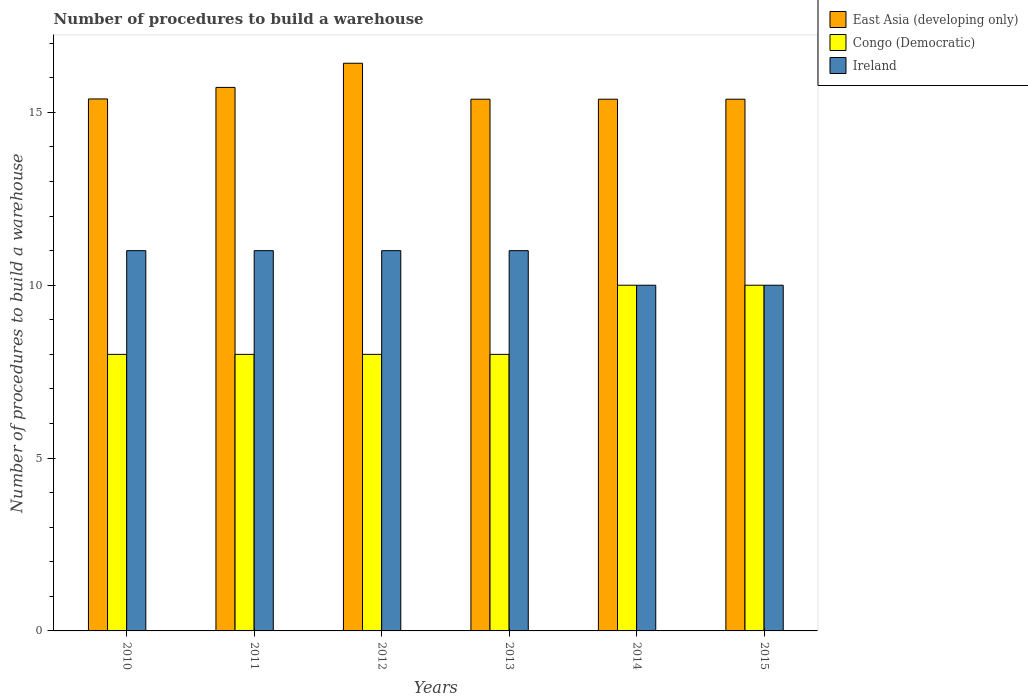How many groups of bars are there?
Provide a succinct answer. 6. Are the number of bars per tick equal to the number of legend labels?
Provide a succinct answer. Yes. How many bars are there on the 2nd tick from the right?
Provide a succinct answer. 3. What is the label of the 2nd group of bars from the left?
Keep it short and to the point. 2011. What is the number of procedures to build a warehouse in in East Asia (developing only) in 2014?
Keep it short and to the point. 15.38. Across all years, what is the maximum number of procedures to build a warehouse in in East Asia (developing only)?
Keep it short and to the point. 16.42. Across all years, what is the minimum number of procedures to build a warehouse in in East Asia (developing only)?
Keep it short and to the point. 15.38. In which year was the number of procedures to build a warehouse in in Ireland minimum?
Your answer should be compact. 2014. What is the total number of procedures to build a warehouse in in Congo (Democratic) in the graph?
Provide a short and direct response. 52. What is the difference between the number of procedures to build a warehouse in in Congo (Democratic) in 2012 and that in 2015?
Offer a very short reply. -2. What is the difference between the number of procedures to build a warehouse in in Ireland in 2010 and the number of procedures to build a warehouse in in East Asia (developing only) in 2012?
Your answer should be very brief. -5.42. What is the average number of procedures to build a warehouse in in Ireland per year?
Provide a succinct answer. 10.67. In the year 2013, what is the difference between the number of procedures to build a warehouse in in Congo (Democratic) and number of procedures to build a warehouse in in East Asia (developing only)?
Your answer should be very brief. -7.38. Is the number of procedures to build a warehouse in in East Asia (developing only) in 2012 less than that in 2013?
Provide a short and direct response. No. What is the difference between the highest and the second highest number of procedures to build a warehouse in in East Asia (developing only)?
Your answer should be very brief. 0.7. What is the difference between the highest and the lowest number of procedures to build a warehouse in in East Asia (developing only)?
Offer a very short reply. 1.04. In how many years, is the number of procedures to build a warehouse in in Ireland greater than the average number of procedures to build a warehouse in in Ireland taken over all years?
Ensure brevity in your answer.  4. Is the sum of the number of procedures to build a warehouse in in Congo (Democratic) in 2010 and 2014 greater than the maximum number of procedures to build a warehouse in in Ireland across all years?
Keep it short and to the point. Yes. What does the 2nd bar from the left in 2015 represents?
Offer a very short reply. Congo (Democratic). What does the 1st bar from the right in 2011 represents?
Ensure brevity in your answer.  Ireland. Are all the bars in the graph horizontal?
Ensure brevity in your answer.  No. Are the values on the major ticks of Y-axis written in scientific E-notation?
Your answer should be compact. No. Does the graph contain any zero values?
Ensure brevity in your answer.  No. Does the graph contain grids?
Your response must be concise. No. Where does the legend appear in the graph?
Your answer should be very brief. Top right. How are the legend labels stacked?
Keep it short and to the point. Vertical. What is the title of the graph?
Offer a terse response. Number of procedures to build a warehouse. What is the label or title of the Y-axis?
Your answer should be very brief. Number of procedures to build a warehouse. What is the Number of procedures to build a warehouse of East Asia (developing only) in 2010?
Your response must be concise. 15.39. What is the Number of procedures to build a warehouse of Congo (Democratic) in 2010?
Ensure brevity in your answer.  8. What is the Number of procedures to build a warehouse of Ireland in 2010?
Offer a very short reply. 11. What is the Number of procedures to build a warehouse of East Asia (developing only) in 2011?
Offer a terse response. 15.72. What is the Number of procedures to build a warehouse of Congo (Democratic) in 2011?
Provide a short and direct response. 8. What is the Number of procedures to build a warehouse in Ireland in 2011?
Make the answer very short. 11. What is the Number of procedures to build a warehouse in East Asia (developing only) in 2012?
Provide a short and direct response. 16.42. What is the Number of procedures to build a warehouse in Ireland in 2012?
Provide a short and direct response. 11. What is the Number of procedures to build a warehouse of East Asia (developing only) in 2013?
Your answer should be very brief. 15.38. What is the Number of procedures to build a warehouse in Ireland in 2013?
Ensure brevity in your answer.  11. What is the Number of procedures to build a warehouse of East Asia (developing only) in 2014?
Ensure brevity in your answer.  15.38. What is the Number of procedures to build a warehouse in Congo (Democratic) in 2014?
Give a very brief answer. 10. What is the Number of procedures to build a warehouse of East Asia (developing only) in 2015?
Provide a short and direct response. 15.38. What is the Number of procedures to build a warehouse of Congo (Democratic) in 2015?
Ensure brevity in your answer.  10. Across all years, what is the maximum Number of procedures to build a warehouse in East Asia (developing only)?
Your response must be concise. 16.42. Across all years, what is the minimum Number of procedures to build a warehouse of East Asia (developing only)?
Your answer should be very brief. 15.38. Across all years, what is the minimum Number of procedures to build a warehouse in Congo (Democratic)?
Keep it short and to the point. 8. Across all years, what is the minimum Number of procedures to build a warehouse of Ireland?
Provide a short and direct response. 10. What is the total Number of procedures to build a warehouse of East Asia (developing only) in the graph?
Offer a very short reply. 93.67. What is the total Number of procedures to build a warehouse of Ireland in the graph?
Give a very brief answer. 64. What is the difference between the Number of procedures to build a warehouse in East Asia (developing only) in 2010 and that in 2011?
Your answer should be very brief. -0.33. What is the difference between the Number of procedures to build a warehouse of East Asia (developing only) in 2010 and that in 2012?
Your response must be concise. -1.03. What is the difference between the Number of procedures to build a warehouse of Congo (Democratic) in 2010 and that in 2012?
Make the answer very short. 0. What is the difference between the Number of procedures to build a warehouse in East Asia (developing only) in 2010 and that in 2013?
Offer a very short reply. 0.01. What is the difference between the Number of procedures to build a warehouse in Congo (Democratic) in 2010 and that in 2013?
Keep it short and to the point. 0. What is the difference between the Number of procedures to build a warehouse of Ireland in 2010 and that in 2013?
Offer a terse response. 0. What is the difference between the Number of procedures to build a warehouse in East Asia (developing only) in 2010 and that in 2014?
Ensure brevity in your answer.  0.01. What is the difference between the Number of procedures to build a warehouse of Congo (Democratic) in 2010 and that in 2014?
Your answer should be compact. -2. What is the difference between the Number of procedures to build a warehouse of East Asia (developing only) in 2010 and that in 2015?
Make the answer very short. 0.01. What is the difference between the Number of procedures to build a warehouse of East Asia (developing only) in 2011 and that in 2012?
Provide a short and direct response. -0.7. What is the difference between the Number of procedures to build a warehouse in Ireland in 2011 and that in 2012?
Keep it short and to the point. 0. What is the difference between the Number of procedures to build a warehouse in East Asia (developing only) in 2011 and that in 2013?
Provide a succinct answer. 0.34. What is the difference between the Number of procedures to build a warehouse of Congo (Democratic) in 2011 and that in 2013?
Keep it short and to the point. 0. What is the difference between the Number of procedures to build a warehouse in Ireland in 2011 and that in 2013?
Offer a terse response. 0. What is the difference between the Number of procedures to build a warehouse of East Asia (developing only) in 2011 and that in 2014?
Offer a very short reply. 0.34. What is the difference between the Number of procedures to build a warehouse of Congo (Democratic) in 2011 and that in 2014?
Your answer should be compact. -2. What is the difference between the Number of procedures to build a warehouse of East Asia (developing only) in 2011 and that in 2015?
Provide a succinct answer. 0.34. What is the difference between the Number of procedures to build a warehouse in East Asia (developing only) in 2012 and that in 2013?
Offer a very short reply. 1.04. What is the difference between the Number of procedures to build a warehouse in East Asia (developing only) in 2012 and that in 2014?
Ensure brevity in your answer.  1.04. What is the difference between the Number of procedures to build a warehouse in Congo (Democratic) in 2012 and that in 2014?
Keep it short and to the point. -2. What is the difference between the Number of procedures to build a warehouse of Ireland in 2012 and that in 2014?
Offer a very short reply. 1. What is the difference between the Number of procedures to build a warehouse in East Asia (developing only) in 2012 and that in 2015?
Offer a terse response. 1.04. What is the difference between the Number of procedures to build a warehouse in East Asia (developing only) in 2013 and that in 2014?
Your answer should be compact. 0. What is the difference between the Number of procedures to build a warehouse in Ireland in 2013 and that in 2014?
Offer a very short reply. 1. What is the difference between the Number of procedures to build a warehouse of East Asia (developing only) in 2013 and that in 2015?
Offer a very short reply. 0. What is the difference between the Number of procedures to build a warehouse of Congo (Democratic) in 2013 and that in 2015?
Provide a succinct answer. -2. What is the difference between the Number of procedures to build a warehouse in Ireland in 2013 and that in 2015?
Offer a terse response. 1. What is the difference between the Number of procedures to build a warehouse in Congo (Democratic) in 2014 and that in 2015?
Your response must be concise. 0. What is the difference between the Number of procedures to build a warehouse in Ireland in 2014 and that in 2015?
Offer a very short reply. 0. What is the difference between the Number of procedures to build a warehouse in East Asia (developing only) in 2010 and the Number of procedures to build a warehouse in Congo (Democratic) in 2011?
Provide a short and direct response. 7.39. What is the difference between the Number of procedures to build a warehouse of East Asia (developing only) in 2010 and the Number of procedures to build a warehouse of Ireland in 2011?
Ensure brevity in your answer.  4.39. What is the difference between the Number of procedures to build a warehouse of East Asia (developing only) in 2010 and the Number of procedures to build a warehouse of Congo (Democratic) in 2012?
Keep it short and to the point. 7.39. What is the difference between the Number of procedures to build a warehouse in East Asia (developing only) in 2010 and the Number of procedures to build a warehouse in Ireland in 2012?
Your answer should be compact. 4.39. What is the difference between the Number of procedures to build a warehouse of Congo (Democratic) in 2010 and the Number of procedures to build a warehouse of Ireland in 2012?
Your answer should be compact. -3. What is the difference between the Number of procedures to build a warehouse in East Asia (developing only) in 2010 and the Number of procedures to build a warehouse in Congo (Democratic) in 2013?
Your response must be concise. 7.39. What is the difference between the Number of procedures to build a warehouse of East Asia (developing only) in 2010 and the Number of procedures to build a warehouse of Ireland in 2013?
Offer a very short reply. 4.39. What is the difference between the Number of procedures to build a warehouse of East Asia (developing only) in 2010 and the Number of procedures to build a warehouse of Congo (Democratic) in 2014?
Offer a very short reply. 5.39. What is the difference between the Number of procedures to build a warehouse of East Asia (developing only) in 2010 and the Number of procedures to build a warehouse of Ireland in 2014?
Ensure brevity in your answer.  5.39. What is the difference between the Number of procedures to build a warehouse of Congo (Democratic) in 2010 and the Number of procedures to build a warehouse of Ireland in 2014?
Give a very brief answer. -2. What is the difference between the Number of procedures to build a warehouse of East Asia (developing only) in 2010 and the Number of procedures to build a warehouse of Congo (Democratic) in 2015?
Keep it short and to the point. 5.39. What is the difference between the Number of procedures to build a warehouse in East Asia (developing only) in 2010 and the Number of procedures to build a warehouse in Ireland in 2015?
Your response must be concise. 5.39. What is the difference between the Number of procedures to build a warehouse in Congo (Democratic) in 2010 and the Number of procedures to build a warehouse in Ireland in 2015?
Give a very brief answer. -2. What is the difference between the Number of procedures to build a warehouse of East Asia (developing only) in 2011 and the Number of procedures to build a warehouse of Congo (Democratic) in 2012?
Provide a succinct answer. 7.72. What is the difference between the Number of procedures to build a warehouse in East Asia (developing only) in 2011 and the Number of procedures to build a warehouse in Ireland in 2012?
Make the answer very short. 4.72. What is the difference between the Number of procedures to build a warehouse in East Asia (developing only) in 2011 and the Number of procedures to build a warehouse in Congo (Democratic) in 2013?
Provide a succinct answer. 7.72. What is the difference between the Number of procedures to build a warehouse in East Asia (developing only) in 2011 and the Number of procedures to build a warehouse in Ireland in 2013?
Offer a terse response. 4.72. What is the difference between the Number of procedures to build a warehouse in Congo (Democratic) in 2011 and the Number of procedures to build a warehouse in Ireland in 2013?
Offer a very short reply. -3. What is the difference between the Number of procedures to build a warehouse of East Asia (developing only) in 2011 and the Number of procedures to build a warehouse of Congo (Democratic) in 2014?
Offer a very short reply. 5.72. What is the difference between the Number of procedures to build a warehouse of East Asia (developing only) in 2011 and the Number of procedures to build a warehouse of Ireland in 2014?
Your answer should be compact. 5.72. What is the difference between the Number of procedures to build a warehouse of Congo (Democratic) in 2011 and the Number of procedures to build a warehouse of Ireland in 2014?
Give a very brief answer. -2. What is the difference between the Number of procedures to build a warehouse in East Asia (developing only) in 2011 and the Number of procedures to build a warehouse in Congo (Democratic) in 2015?
Give a very brief answer. 5.72. What is the difference between the Number of procedures to build a warehouse in East Asia (developing only) in 2011 and the Number of procedures to build a warehouse in Ireland in 2015?
Your answer should be very brief. 5.72. What is the difference between the Number of procedures to build a warehouse in Congo (Democratic) in 2011 and the Number of procedures to build a warehouse in Ireland in 2015?
Ensure brevity in your answer.  -2. What is the difference between the Number of procedures to build a warehouse in East Asia (developing only) in 2012 and the Number of procedures to build a warehouse in Congo (Democratic) in 2013?
Keep it short and to the point. 8.42. What is the difference between the Number of procedures to build a warehouse in East Asia (developing only) in 2012 and the Number of procedures to build a warehouse in Ireland in 2013?
Your answer should be compact. 5.42. What is the difference between the Number of procedures to build a warehouse of East Asia (developing only) in 2012 and the Number of procedures to build a warehouse of Congo (Democratic) in 2014?
Your answer should be compact. 6.42. What is the difference between the Number of procedures to build a warehouse of East Asia (developing only) in 2012 and the Number of procedures to build a warehouse of Ireland in 2014?
Offer a very short reply. 6.42. What is the difference between the Number of procedures to build a warehouse of Congo (Democratic) in 2012 and the Number of procedures to build a warehouse of Ireland in 2014?
Provide a short and direct response. -2. What is the difference between the Number of procedures to build a warehouse of East Asia (developing only) in 2012 and the Number of procedures to build a warehouse of Congo (Democratic) in 2015?
Give a very brief answer. 6.42. What is the difference between the Number of procedures to build a warehouse of East Asia (developing only) in 2012 and the Number of procedures to build a warehouse of Ireland in 2015?
Provide a succinct answer. 6.42. What is the difference between the Number of procedures to build a warehouse of Congo (Democratic) in 2012 and the Number of procedures to build a warehouse of Ireland in 2015?
Your answer should be very brief. -2. What is the difference between the Number of procedures to build a warehouse in East Asia (developing only) in 2013 and the Number of procedures to build a warehouse in Congo (Democratic) in 2014?
Your answer should be very brief. 5.38. What is the difference between the Number of procedures to build a warehouse of East Asia (developing only) in 2013 and the Number of procedures to build a warehouse of Ireland in 2014?
Your response must be concise. 5.38. What is the difference between the Number of procedures to build a warehouse in Congo (Democratic) in 2013 and the Number of procedures to build a warehouse in Ireland in 2014?
Provide a short and direct response. -2. What is the difference between the Number of procedures to build a warehouse of East Asia (developing only) in 2013 and the Number of procedures to build a warehouse of Congo (Democratic) in 2015?
Provide a succinct answer. 5.38. What is the difference between the Number of procedures to build a warehouse in East Asia (developing only) in 2013 and the Number of procedures to build a warehouse in Ireland in 2015?
Your answer should be compact. 5.38. What is the difference between the Number of procedures to build a warehouse of Congo (Democratic) in 2013 and the Number of procedures to build a warehouse of Ireland in 2015?
Make the answer very short. -2. What is the difference between the Number of procedures to build a warehouse in East Asia (developing only) in 2014 and the Number of procedures to build a warehouse in Congo (Democratic) in 2015?
Ensure brevity in your answer.  5.38. What is the difference between the Number of procedures to build a warehouse of East Asia (developing only) in 2014 and the Number of procedures to build a warehouse of Ireland in 2015?
Keep it short and to the point. 5.38. What is the difference between the Number of procedures to build a warehouse of Congo (Democratic) in 2014 and the Number of procedures to build a warehouse of Ireland in 2015?
Provide a short and direct response. 0. What is the average Number of procedures to build a warehouse of East Asia (developing only) per year?
Provide a short and direct response. 15.61. What is the average Number of procedures to build a warehouse in Congo (Democratic) per year?
Your answer should be very brief. 8.67. What is the average Number of procedures to build a warehouse in Ireland per year?
Provide a succinct answer. 10.67. In the year 2010, what is the difference between the Number of procedures to build a warehouse in East Asia (developing only) and Number of procedures to build a warehouse in Congo (Democratic)?
Ensure brevity in your answer.  7.39. In the year 2010, what is the difference between the Number of procedures to build a warehouse of East Asia (developing only) and Number of procedures to build a warehouse of Ireland?
Give a very brief answer. 4.39. In the year 2011, what is the difference between the Number of procedures to build a warehouse in East Asia (developing only) and Number of procedures to build a warehouse in Congo (Democratic)?
Your answer should be very brief. 7.72. In the year 2011, what is the difference between the Number of procedures to build a warehouse in East Asia (developing only) and Number of procedures to build a warehouse in Ireland?
Your answer should be compact. 4.72. In the year 2012, what is the difference between the Number of procedures to build a warehouse in East Asia (developing only) and Number of procedures to build a warehouse in Congo (Democratic)?
Provide a succinct answer. 8.42. In the year 2012, what is the difference between the Number of procedures to build a warehouse of East Asia (developing only) and Number of procedures to build a warehouse of Ireland?
Your answer should be compact. 5.42. In the year 2013, what is the difference between the Number of procedures to build a warehouse of East Asia (developing only) and Number of procedures to build a warehouse of Congo (Democratic)?
Keep it short and to the point. 7.38. In the year 2013, what is the difference between the Number of procedures to build a warehouse in East Asia (developing only) and Number of procedures to build a warehouse in Ireland?
Provide a succinct answer. 4.38. In the year 2013, what is the difference between the Number of procedures to build a warehouse of Congo (Democratic) and Number of procedures to build a warehouse of Ireland?
Offer a terse response. -3. In the year 2014, what is the difference between the Number of procedures to build a warehouse in East Asia (developing only) and Number of procedures to build a warehouse in Congo (Democratic)?
Your answer should be compact. 5.38. In the year 2014, what is the difference between the Number of procedures to build a warehouse of East Asia (developing only) and Number of procedures to build a warehouse of Ireland?
Offer a terse response. 5.38. In the year 2015, what is the difference between the Number of procedures to build a warehouse in East Asia (developing only) and Number of procedures to build a warehouse in Congo (Democratic)?
Offer a very short reply. 5.38. In the year 2015, what is the difference between the Number of procedures to build a warehouse in East Asia (developing only) and Number of procedures to build a warehouse in Ireland?
Provide a succinct answer. 5.38. What is the ratio of the Number of procedures to build a warehouse of East Asia (developing only) in 2010 to that in 2011?
Provide a short and direct response. 0.98. What is the ratio of the Number of procedures to build a warehouse in Congo (Democratic) in 2010 to that in 2011?
Offer a terse response. 1. What is the ratio of the Number of procedures to build a warehouse of Ireland in 2010 to that in 2011?
Provide a short and direct response. 1. What is the ratio of the Number of procedures to build a warehouse of East Asia (developing only) in 2010 to that in 2012?
Give a very brief answer. 0.94. What is the ratio of the Number of procedures to build a warehouse of Congo (Democratic) in 2010 to that in 2012?
Provide a short and direct response. 1. What is the ratio of the Number of procedures to build a warehouse in Ireland in 2010 to that in 2012?
Make the answer very short. 1. What is the ratio of the Number of procedures to build a warehouse in East Asia (developing only) in 2010 to that in 2013?
Make the answer very short. 1. What is the ratio of the Number of procedures to build a warehouse of Ireland in 2010 to that in 2013?
Your answer should be compact. 1. What is the ratio of the Number of procedures to build a warehouse in Congo (Democratic) in 2010 to that in 2015?
Make the answer very short. 0.8. What is the ratio of the Number of procedures to build a warehouse in East Asia (developing only) in 2011 to that in 2012?
Offer a very short reply. 0.96. What is the ratio of the Number of procedures to build a warehouse in Congo (Democratic) in 2011 to that in 2012?
Make the answer very short. 1. What is the ratio of the Number of procedures to build a warehouse of Ireland in 2011 to that in 2012?
Ensure brevity in your answer.  1. What is the ratio of the Number of procedures to build a warehouse in East Asia (developing only) in 2011 to that in 2013?
Keep it short and to the point. 1.02. What is the ratio of the Number of procedures to build a warehouse in Congo (Democratic) in 2011 to that in 2013?
Ensure brevity in your answer.  1. What is the ratio of the Number of procedures to build a warehouse of East Asia (developing only) in 2011 to that in 2014?
Offer a terse response. 1.02. What is the ratio of the Number of procedures to build a warehouse in Congo (Democratic) in 2011 to that in 2014?
Offer a very short reply. 0.8. What is the ratio of the Number of procedures to build a warehouse in East Asia (developing only) in 2011 to that in 2015?
Give a very brief answer. 1.02. What is the ratio of the Number of procedures to build a warehouse in East Asia (developing only) in 2012 to that in 2013?
Provide a succinct answer. 1.07. What is the ratio of the Number of procedures to build a warehouse in Ireland in 2012 to that in 2013?
Keep it short and to the point. 1. What is the ratio of the Number of procedures to build a warehouse of East Asia (developing only) in 2012 to that in 2014?
Offer a very short reply. 1.07. What is the ratio of the Number of procedures to build a warehouse of East Asia (developing only) in 2012 to that in 2015?
Your answer should be very brief. 1.07. What is the ratio of the Number of procedures to build a warehouse in Ireland in 2012 to that in 2015?
Provide a succinct answer. 1.1. What is the ratio of the Number of procedures to build a warehouse of East Asia (developing only) in 2013 to that in 2014?
Provide a succinct answer. 1. What is the ratio of the Number of procedures to build a warehouse in Ireland in 2013 to that in 2014?
Offer a very short reply. 1.1. What is the ratio of the Number of procedures to build a warehouse of East Asia (developing only) in 2013 to that in 2015?
Make the answer very short. 1. What is the ratio of the Number of procedures to build a warehouse of Congo (Democratic) in 2013 to that in 2015?
Make the answer very short. 0.8. What is the ratio of the Number of procedures to build a warehouse of East Asia (developing only) in 2014 to that in 2015?
Give a very brief answer. 1. What is the difference between the highest and the second highest Number of procedures to build a warehouse in East Asia (developing only)?
Make the answer very short. 0.7. What is the difference between the highest and the lowest Number of procedures to build a warehouse in East Asia (developing only)?
Provide a succinct answer. 1.04. 